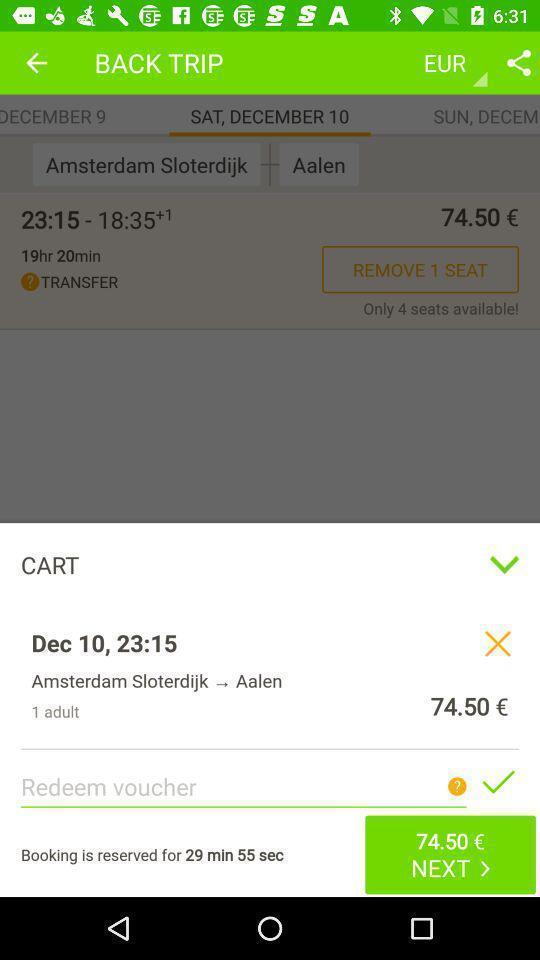Describe the content in this image. Pop up page displaying cart details. 